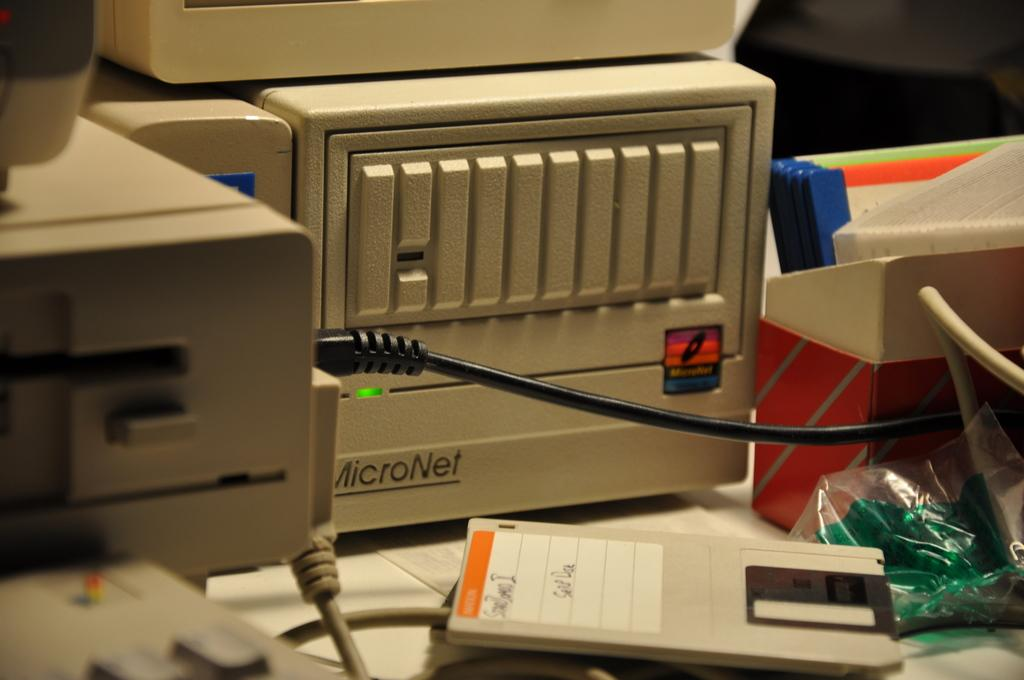<image>
Create a compact narrative representing the image presented. A computer with MicroNet on it and a disk sitting on the table in front of it. 